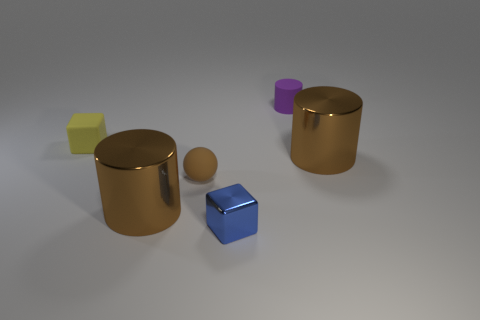How many brown cylinders must be subtracted to get 1 brown cylinders? 1 Add 3 shiny cylinders. How many objects exist? 9 Subtract all blocks. How many objects are left? 4 Subtract 1 brown cylinders. How many objects are left? 5 Subtract all large green metallic cylinders. Subtract all blue objects. How many objects are left? 5 Add 1 small yellow things. How many small yellow things are left? 2 Add 4 large red metal balls. How many large red metal balls exist? 4 